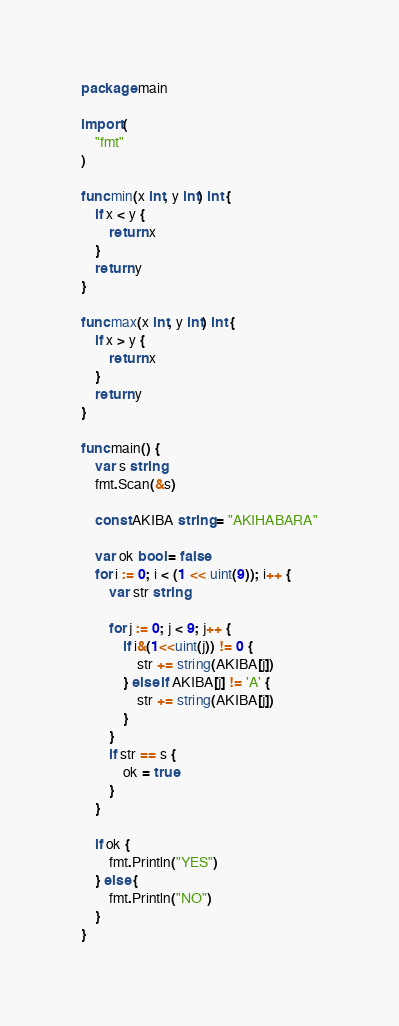<code> <loc_0><loc_0><loc_500><loc_500><_Go_>package main

import (
	"fmt"
)

func min(x int, y int) int {
	if x < y {
		return x
	}
	return y
}

func max(x int, y int) int {
	if x > y {
		return x
	}
	return y
}

func main() {
	var s string
	fmt.Scan(&s)

	const AKIBA string = "AKIHABARA"

	var ok bool = false
	for i := 0; i < (1 << uint(9)); i++ {
		var str string

		for j := 0; j < 9; j++ {
			if i&(1<<uint(j)) != 0 {
				str += string(AKIBA[j])
			} else if AKIBA[j] != 'A' {
				str += string(AKIBA[j])
			}
		}
		if str == s {
			ok = true
		}
	}

	if ok {
		fmt.Println("YES")
	} else {
		fmt.Println("NO")
	}
}
</code> 